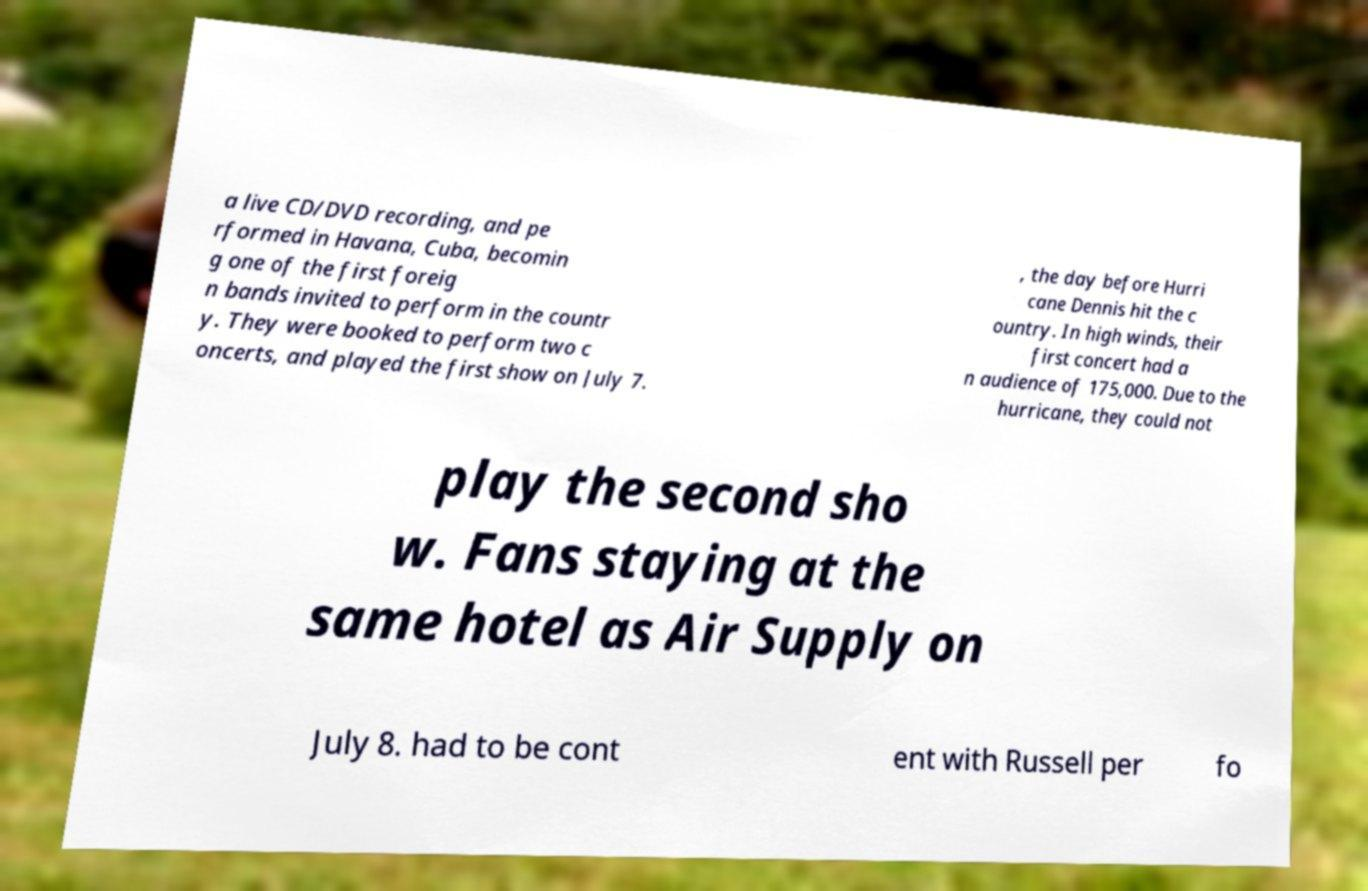Could you extract and type out the text from this image? a live CD/DVD recording, and pe rformed in Havana, Cuba, becomin g one of the first foreig n bands invited to perform in the countr y. They were booked to perform two c oncerts, and played the first show on July 7. , the day before Hurri cane Dennis hit the c ountry. In high winds, their first concert had a n audience of 175,000. Due to the hurricane, they could not play the second sho w. Fans staying at the same hotel as Air Supply on July 8. had to be cont ent with Russell per fo 